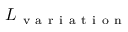Convert formula to latex. <formula><loc_0><loc_0><loc_500><loc_500>L _ { v a r i a t i o n }</formula> 